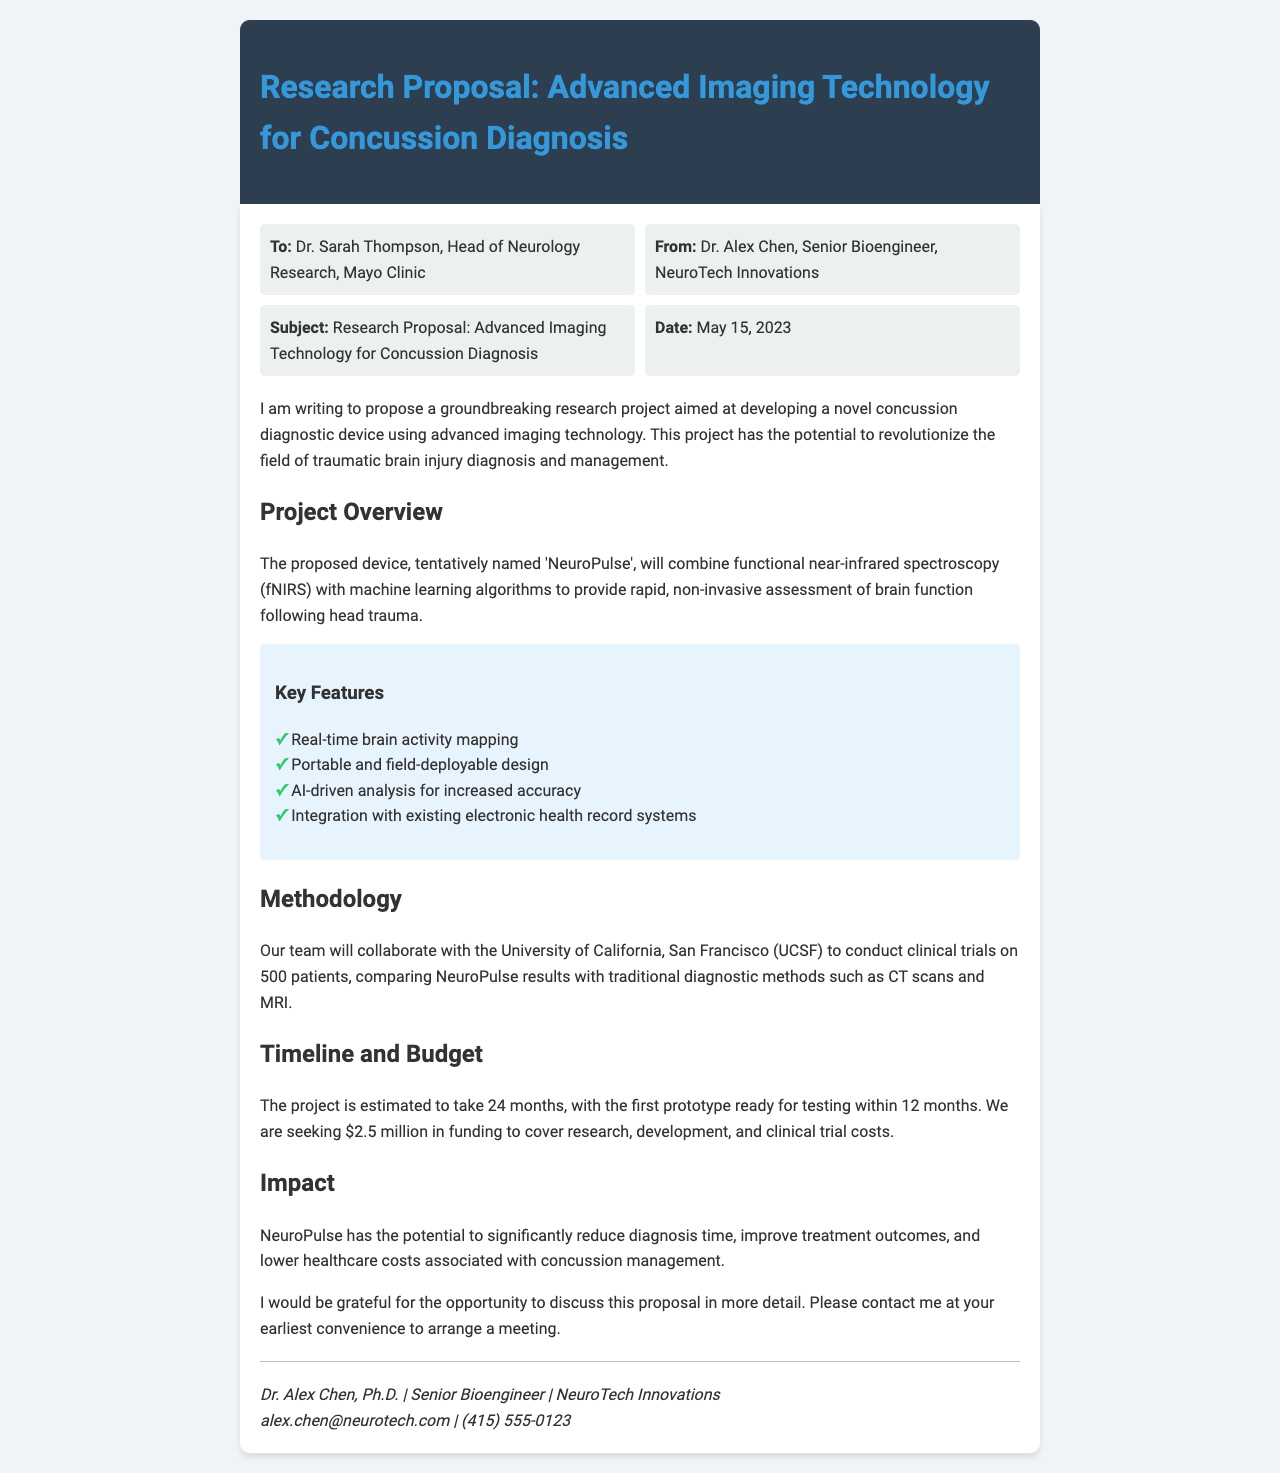what is the name of the proposed device? The name of the proposed device is introduced in the project overview section as 'NeuroPulse'.
Answer: NeuroPulse who is the recipient of the fax? The recipient is mentioned in the header information as Dr. Sarah Thompson, Head of Neurology Research, Mayo Clinic.
Answer: Dr. Sarah Thompson what is the amount of funding being sought? The funding amount is specified in the timeline and budget section as $2.5 million.
Answer: $2.5 million how long is the estimated timeline for the project? The timeline for the project is mentioned in the timeline and budget section, estimating it to take 24 months.
Answer: 24 months which institution is collaborating on the clinical trials? The institution collaborating on the clinical trials is stated as the University of California, San Francisco (UCSF).
Answer: UCSF what key feature aids in analysis accuracy? The document mentions an AI-driven analysis as a key feature that aids in increased accuracy.
Answer: AI-driven analysis who is the sender of the fax? The sender is identified in the header information as Dr. Alex Chen, Senior Bioengineer, NeuroTech Innovations.
Answer: Dr. Alex Chen when was the fax sent? The date the fax was sent is specified in the header information as May 15, 2023.
Answer: May 15, 2023 what is the main objective of the proposed research project? The main objective is outlined in the introduction as developing a novel concussion diagnostic device using advanced imaging technology.
Answer: developing a novel concussion diagnostic device 